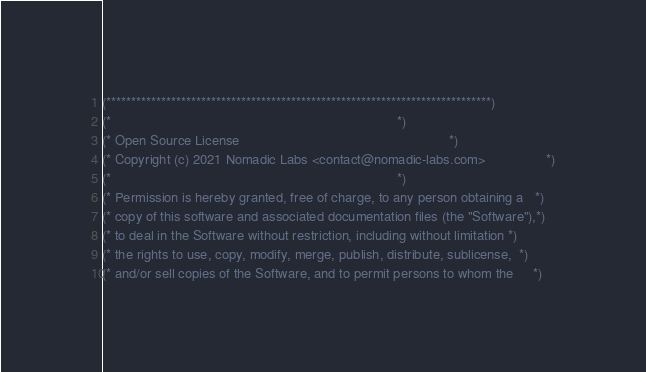<code> <loc_0><loc_0><loc_500><loc_500><_OCaml_>(*****************************************************************************)
(*                                                                           *)
(* Open Source License                                                       *)
(* Copyright (c) 2021 Nomadic Labs <contact@nomadic-labs.com>                *)
(*                                                                           *)
(* Permission is hereby granted, free of charge, to any person obtaining a   *)
(* copy of this software and associated documentation files (the "Software"),*)
(* to deal in the Software without restriction, including without limitation *)
(* the rights to use, copy, modify, merge, publish, distribute, sublicense,  *)
(* and/or sell copies of the Software, and to permit persons to whom the     *)</code> 